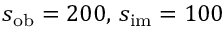Convert formula to latex. <formula><loc_0><loc_0><loc_500><loc_500>s _ { o b } = 2 0 0 , \, s _ { i m } = 1 0 0</formula> 